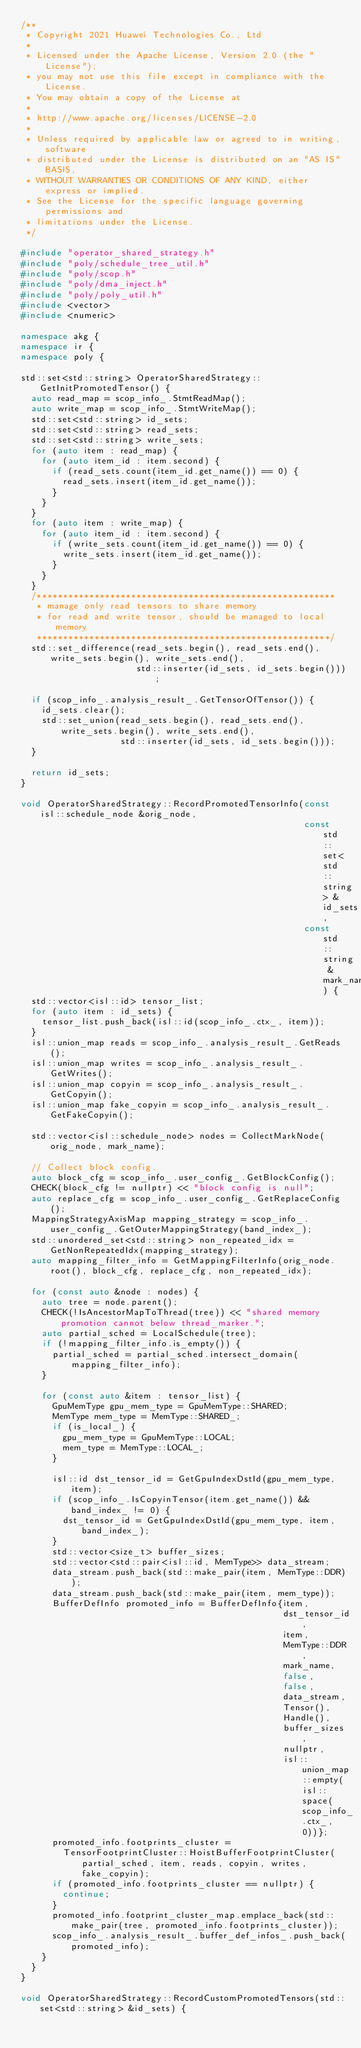<code> <loc_0><loc_0><loc_500><loc_500><_C++_>/**
 * Copyright 2021 Huawei Technologies Co., Ltd
 *
 * Licensed under the Apache License, Version 2.0 (the "License");
 * you may not use this file except in compliance with the License.
 * You may obtain a copy of the License at
 *
 * http://www.apache.org/licenses/LICENSE-2.0
 *
 * Unless required by applicable law or agreed to in writing, software
 * distributed under the License is distributed on an "AS IS" BASIS,
 * WITHOUT WARRANTIES OR CONDITIONS OF ANY KIND, either express or implied.
 * See the License for the specific language governing permissions and
 * limitations under the License.
 */

#include "operator_shared_strategy.h"
#include "poly/schedule_tree_util.h"
#include "poly/scop.h"
#include "poly/dma_inject.h"
#include "poly/poly_util.h"
#include <vector>
#include <numeric>

namespace akg {
namespace ir {
namespace poly {

std::set<std::string> OperatorSharedStrategy::GetInitPromotedTensor() {
  auto read_map = scop_info_.StmtReadMap();
  auto write_map = scop_info_.StmtWriteMap();
  std::set<std::string> id_sets;
  std::set<std::string> read_sets;
  std::set<std::string> write_sets;
  for (auto item : read_map) {
    for (auto item_id : item.second) {
      if (read_sets.count(item_id.get_name()) == 0) {
        read_sets.insert(item_id.get_name());
      }
    }
  }
  for (auto item : write_map) {
    for (auto item_id : item.second) {
      if (write_sets.count(item_id.get_name()) == 0) {
        write_sets.insert(item_id.get_name());
      }
    }
  }
  /*********************************************************
   * manage only read tensors to share memory
   * for read and write tensor, should be managed to local memory
   ********************************************************/
  std::set_difference(read_sets.begin(), read_sets.end(), write_sets.begin(), write_sets.end(),
                      std::inserter(id_sets, id_sets.begin()));

  if (scop_info_.analysis_result_.GetTensorOfTensor()) {
    id_sets.clear();
    std::set_union(read_sets.begin(), read_sets.end(), write_sets.begin(), write_sets.end(),
                   std::inserter(id_sets, id_sets.begin()));
  }

  return id_sets;
}

void OperatorSharedStrategy::RecordPromotedTensorInfo(const isl::schedule_node &orig_node,
                                                      const std::set<std::string> &id_sets,
                                                      const std::string &mark_name) {
  std::vector<isl::id> tensor_list;
  for (auto item : id_sets) {
    tensor_list.push_back(isl::id(scop_info_.ctx_, item));
  }
  isl::union_map reads = scop_info_.analysis_result_.GetReads();
  isl::union_map writes = scop_info_.analysis_result_.GetWrites();
  isl::union_map copyin = scop_info_.analysis_result_.GetCopyin();
  isl::union_map fake_copyin = scop_info_.analysis_result_.GetFakeCopyin();

  std::vector<isl::schedule_node> nodes = CollectMarkNode(orig_node, mark_name);

  // Collect block config.
  auto block_cfg = scop_info_.user_config_.GetBlockConfig();
  CHECK(block_cfg != nullptr) << "block config is null";
  auto replace_cfg = scop_info_.user_config_.GetReplaceConfig();
  MappingStrategyAxisMap mapping_strategy = scop_info_.user_config_.GetOuterMappingStrategy(band_index_);
  std::unordered_set<std::string> non_repeated_idx = GetNonRepeatedIdx(mapping_strategy);
  auto mapping_filter_info = GetMappingFilterInfo(orig_node.root(), block_cfg, replace_cfg, non_repeated_idx);

  for (const auto &node : nodes) {
    auto tree = node.parent();
    CHECK(!IsAncestorMapToThread(tree)) << "shared memory promotion cannot below thread_marker.";
    auto partial_sched = LocalSchedule(tree);
    if (!mapping_filter_info.is_empty()) {
      partial_sched = partial_sched.intersect_domain(mapping_filter_info);
    }

    for (const auto &item : tensor_list) {
      GpuMemType gpu_mem_type = GpuMemType::SHARED;
      MemType mem_type = MemType::SHARED_;
      if (is_local_) {
        gpu_mem_type = GpuMemType::LOCAL;
        mem_type = MemType::LOCAL_;
      }

      isl::id dst_tensor_id = GetGpuIndexDstId(gpu_mem_type, item);
      if (scop_info_.IsCopyinTensor(item.get_name()) && band_index_ != 0) {
        dst_tensor_id = GetGpuIndexDstId(gpu_mem_type, item, band_index_);
      }
      std::vector<size_t> buffer_sizes;
      std::vector<std::pair<isl::id, MemType>> data_stream;
      data_stream.push_back(std::make_pair(item, MemType::DDR));
      data_stream.push_back(std::make_pair(item, mem_type));
      BufferDefInfo promoted_info = BufferDefInfo{item,
                                                  dst_tensor_id,
                                                  item,
                                                  MemType::DDR,
                                                  mark_name,
                                                  false,
                                                  false,
                                                  data_stream,
                                                  Tensor(),
                                                  Handle(),
                                                  buffer_sizes,
                                                  nullptr,
                                                  isl::union_map::empty(isl::space(scop_info_.ctx_, 0))};
      promoted_info.footprints_cluster =
        TensorFootprintCluster::HoistBufferFootprintCluster(partial_sched, item, reads, copyin, writes, fake_copyin);
      if (promoted_info.footprints_cluster == nullptr) {
        continue;
      }
      promoted_info.footprint_cluster_map.emplace_back(std::make_pair(tree, promoted_info.footprints_cluster));
      scop_info_.analysis_result_.buffer_def_infos_.push_back(promoted_info);
    }
  }
}

void OperatorSharedStrategy::RecordCustomPromotedTensors(std::set<std::string> &id_sets) {</code> 